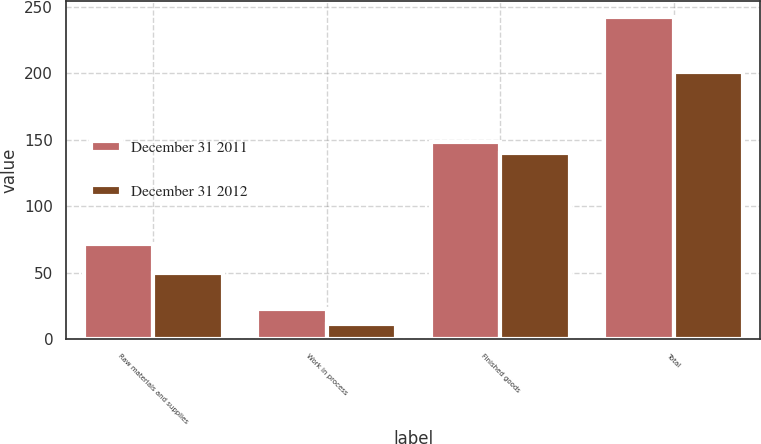Convert chart to OTSL. <chart><loc_0><loc_0><loc_500><loc_500><stacked_bar_chart><ecel><fcel>Raw materials and supplies<fcel>Work in process<fcel>Finished goods<fcel>Total<nl><fcel>December 31 2011<fcel>71.7<fcel>22.4<fcel>148.1<fcel>242.2<nl><fcel>December 31 2012<fcel>49.6<fcel>11.3<fcel>139.8<fcel>200.7<nl></chart> 